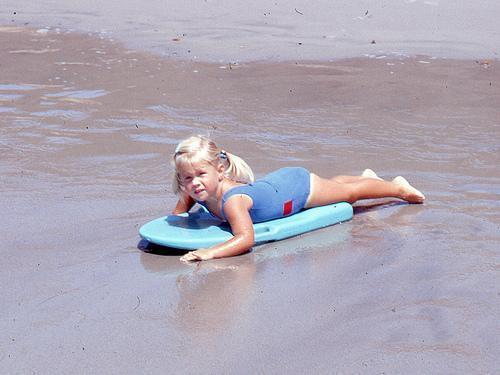How many girls are in the picture?
Give a very brief answer. 1. 